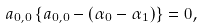Convert formula to latex. <formula><loc_0><loc_0><loc_500><loc_500>a _ { 0 , 0 } \left \{ a _ { 0 , 0 } - ( \alpha _ { 0 } - \alpha _ { 1 } ) \right \} = 0 ,</formula> 